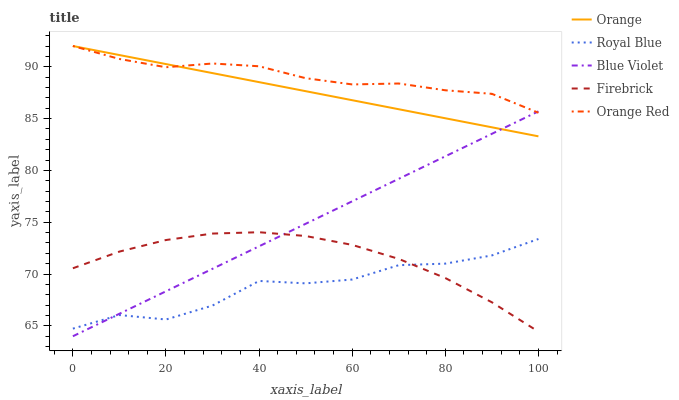Does Firebrick have the minimum area under the curve?
Answer yes or no. No. Does Firebrick have the maximum area under the curve?
Answer yes or no. No. Is Firebrick the smoothest?
Answer yes or no. No. Is Firebrick the roughest?
Answer yes or no. No. Does Royal Blue have the lowest value?
Answer yes or no. No. Does Firebrick have the highest value?
Answer yes or no. No. Is Royal Blue less than Orange Red?
Answer yes or no. Yes. Is Orange greater than Firebrick?
Answer yes or no. Yes. Does Royal Blue intersect Orange Red?
Answer yes or no. No. 